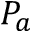Convert formula to latex. <formula><loc_0><loc_0><loc_500><loc_500>P _ { a }</formula> 